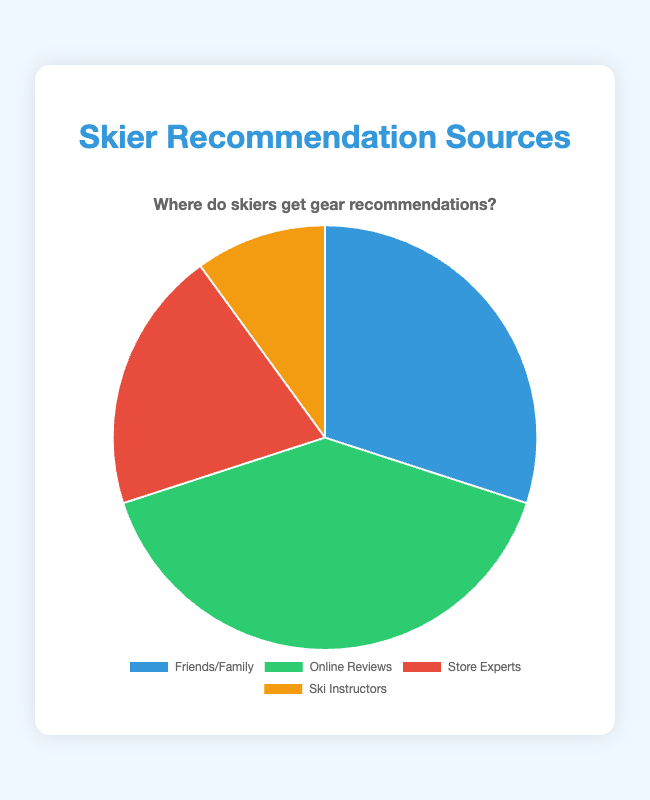What percentage of skiers rely on friends or family for gear recommendations? By looking at the chart, we can see the segment labeled "Friends/Family," which represents 30% of the total recommendations.
Answer: 30% Which source is the least popular for gear recommendations? The segment labeled "Ski Instructors" represents 10%, which is the smallest percentage among all the segments.
Answer: Ski Instructors How does the percentage for online reviews compare to the percentage for store experts? The segment labeled "Online Reviews" represents 40%, and the segment labeled "Store Experts" represents 20%. Thus, online reviews are twice as relied upon as store experts.
Answer: Online Reviews are twice as relied upon as Store Experts What is the combined percentage of skiers who rely on friends/family and store experts? The segment for "Friends/Family" is 30% and "Store Experts" is 20%. Adding these two percentages together gives us 30% + 20% = 50%.
Answer: 50% Which color represents the store experts in the pie chart? By observing the legend, the segment for "Store Experts" is represented by the red color.
Answer: Red What is the difference in percentage points between the most popular and the least popular sources? The most popular source is "Online Reviews" at 40%, and the least popular is "Ski Instructors" at 10%. The difference is 40% - 10% = 30%.
Answer: 30% Are skiers more likely to rely on online reviews or friends/family for gear recommendations? The segment labeled "Online Reviews" represents 40%, while "Friends/Family" represents 30%. Therefore, skiers are more likely to rely on online reviews.
Answer: Online Reviews If the combined value for friends/family and online reviews is 70%, what would the combined value for the other sources be? The combined value for friends/family and online reviews is 30% + 40% = 70%. Total percentage is always 100%, so the combined value for the other sources (store experts and ski instructors) is 100% - 70% = 30%.
Answer: 30% Which two sources together make up exactly half of the pie chart? The segments for "Friends/Family" and "Store Experts" constitute 30% and 20% respectively. Adding these gives us 30% + 20% = 50%.
Answer: Friends/Family and Store Experts 